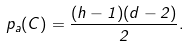<formula> <loc_0><loc_0><loc_500><loc_500>p _ { a } ( C ) = \frac { ( h - 1 ) ( d - 2 ) } { 2 } .</formula> 